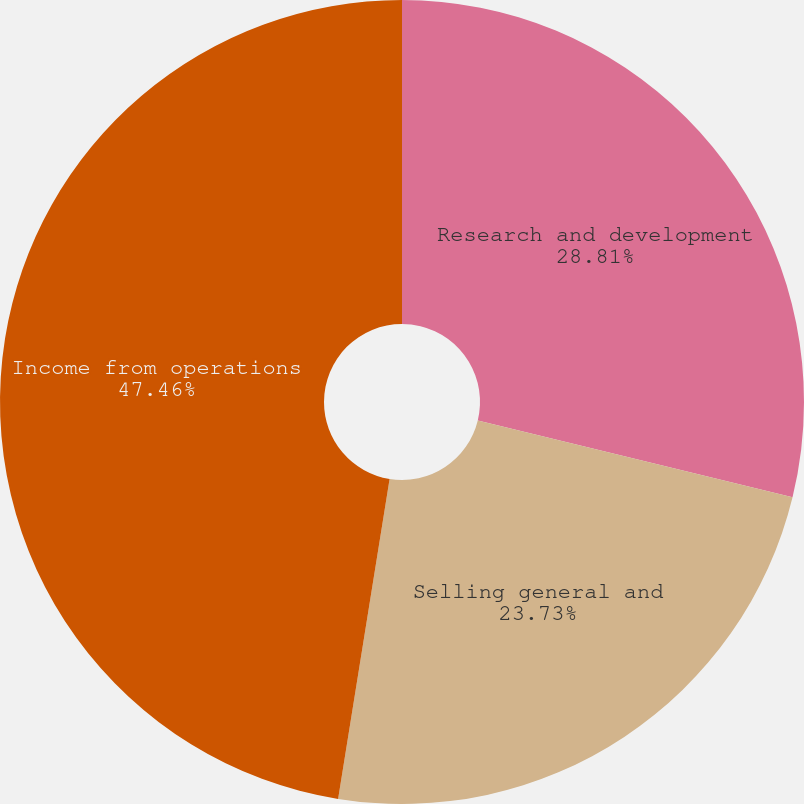Convert chart. <chart><loc_0><loc_0><loc_500><loc_500><pie_chart><fcel>Research and development<fcel>Selling general and<fcel>Income from operations<nl><fcel>28.81%<fcel>23.73%<fcel>47.46%<nl></chart> 